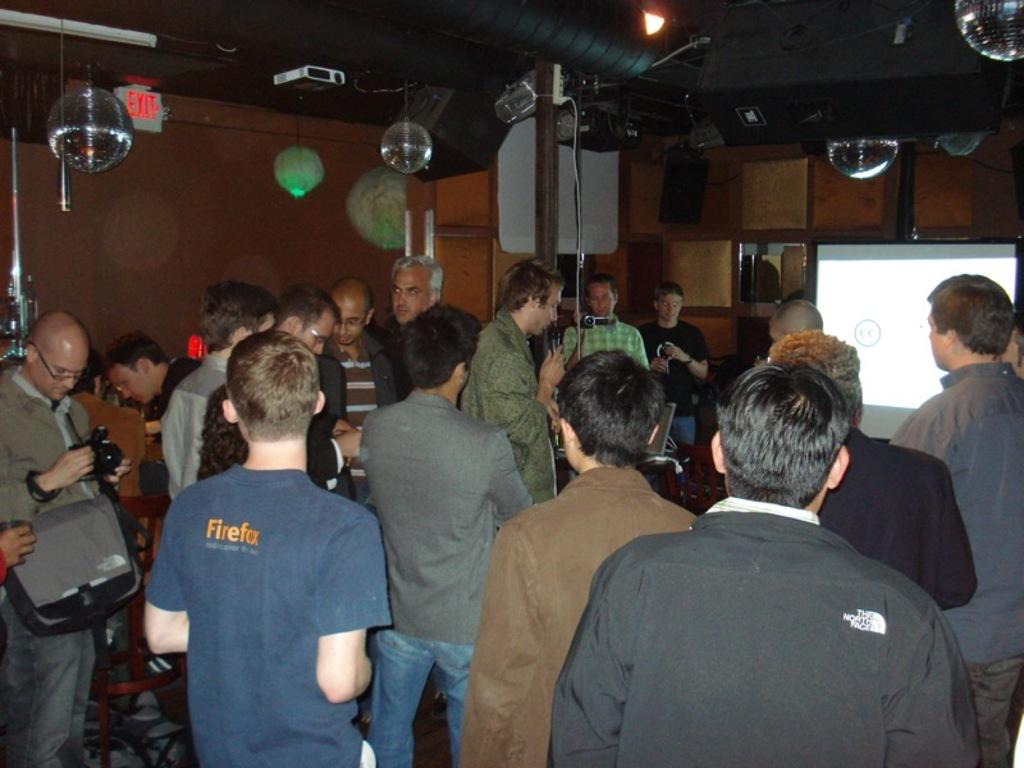How many people are present in the image? There are people in the image, but the exact number is not specified. What can be seen on the screen in the image? The content on the screen is not visible from the provided facts. What is the source of light in the image? The source of light is not specified in the provided facts. What type of speakers are present in the image? The type of speakers is not specified in the provided facts. What are the cameras used for in the image? The purpose of the cameras is not specified in the provided facts. What information is displayed on the exit board in the image? The information on the exit board is not visible from the provided facts. What is the material of the wall in the image? The material of the wall is not specified in the provided facts. What objects are being held by the people in the image? The objects being held by the people are not specified in the provided facts. Can you describe the taste of the cave in the image? There is no cave present in the image, so it is not possible to describe its taste. 